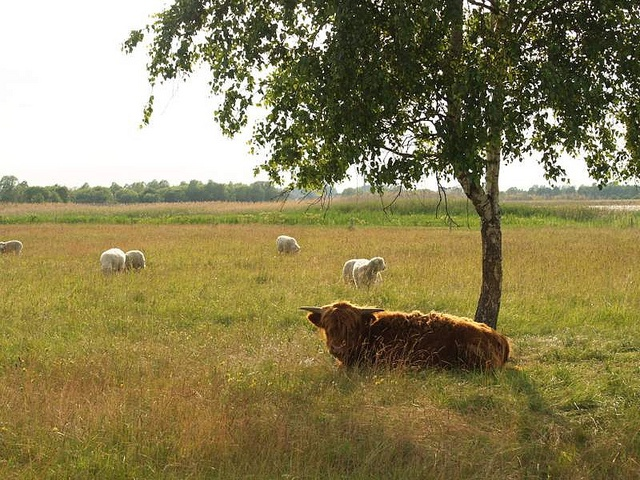Describe the objects in this image and their specific colors. I can see cow in white, black, maroon, and olive tones, sheep in white, olive, tan, and beige tones, sheep in white, tan, beige, and olive tones, sheep in white, olive, tan, and gray tones, and sheep in white, tan, gray, and olive tones in this image. 